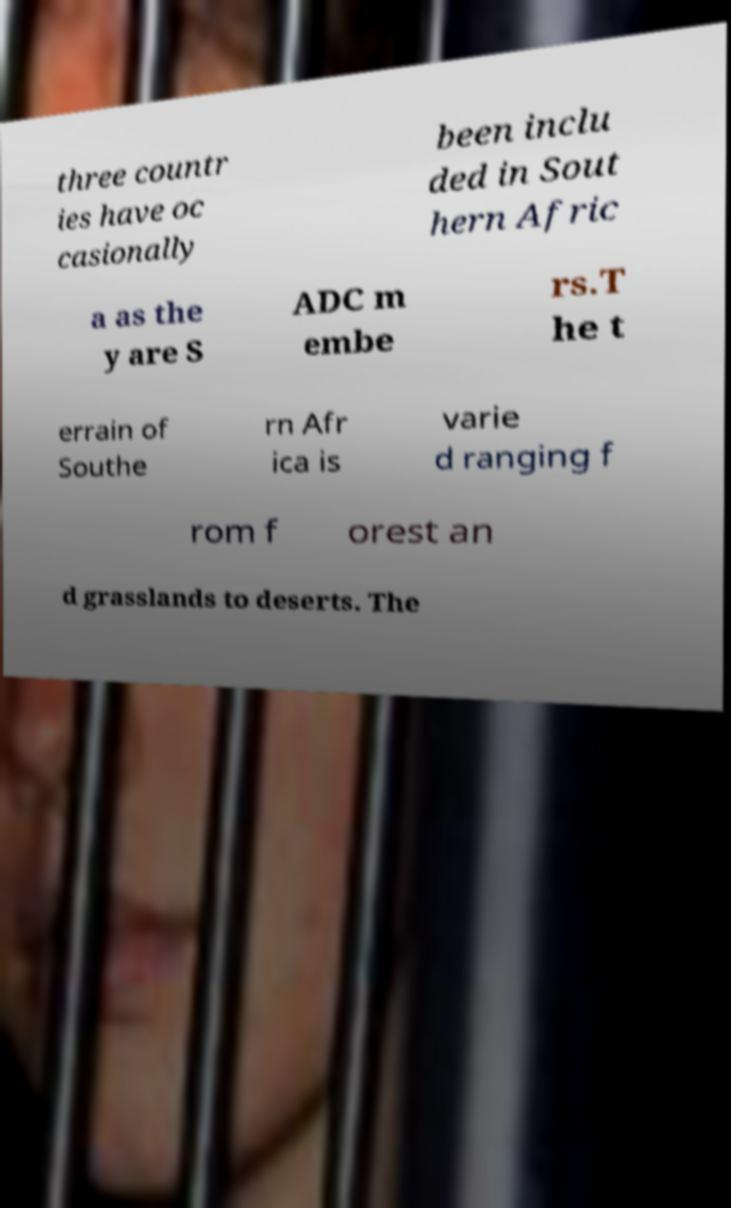There's text embedded in this image that I need extracted. Can you transcribe it verbatim? three countr ies have oc casionally been inclu ded in Sout hern Afric a as the y are S ADC m embe rs.T he t errain of Southe rn Afr ica is varie d ranging f rom f orest an d grasslands to deserts. The 